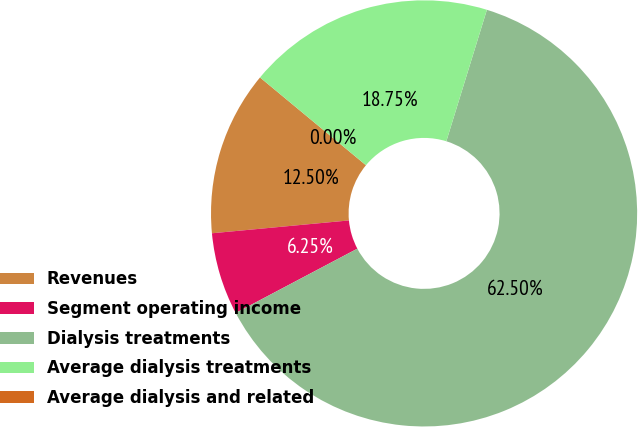<chart> <loc_0><loc_0><loc_500><loc_500><pie_chart><fcel>Revenues<fcel>Segment operating income<fcel>Dialysis treatments<fcel>Average dialysis treatments<fcel>Average dialysis and related<nl><fcel>12.5%<fcel>6.25%<fcel>62.5%<fcel>18.75%<fcel>0.0%<nl></chart> 